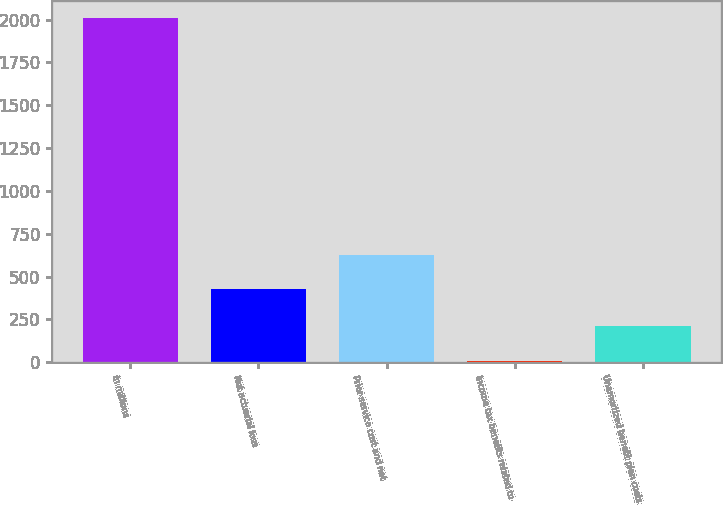Convert chart to OTSL. <chart><loc_0><loc_0><loc_500><loc_500><bar_chart><fcel>in millions<fcel>Net actuarial loss<fcel>Prior service cost and net<fcel>Income tax benefits related to<fcel>Unamortized benefit plan costs<nl><fcel>2007<fcel>429<fcel>628.8<fcel>9<fcel>208.8<nl></chart> 